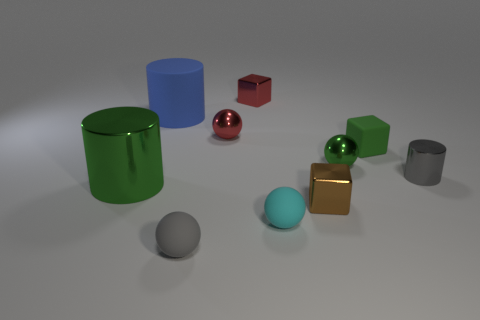Subtract all brown spheres. Subtract all yellow cylinders. How many spheres are left? 4 Subtract all blocks. How many objects are left? 7 Add 4 tiny gray spheres. How many tiny gray spheres are left? 5 Add 3 tiny purple cylinders. How many tiny purple cylinders exist? 3 Subtract 0 yellow balls. How many objects are left? 10 Subtract all yellow matte blocks. Subtract all small cyan things. How many objects are left? 9 